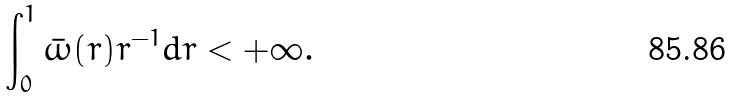<formula> <loc_0><loc_0><loc_500><loc_500>\int _ { 0 } ^ { 1 } \bar { \omega } ( r ) r ^ { - 1 } d r < + \infty .</formula> 